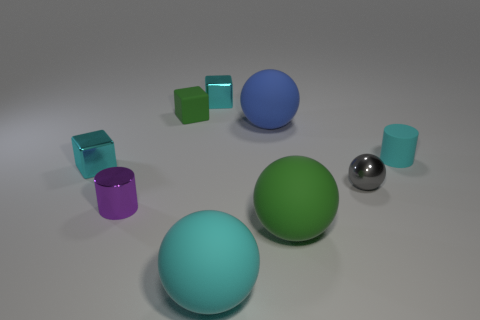What material is the ball that is the same color as the small rubber cube?
Your answer should be compact. Rubber. The green matte cube is what size?
Keep it short and to the point. Small. What number of other things are there of the same color as the shiny cylinder?
Provide a short and direct response. 0. Is the material of the cylinder in front of the small gray ball the same as the cyan cylinder?
Provide a succinct answer. No. Are there fewer cyan cubes to the left of the tiny purple object than small blocks on the left side of the big blue ball?
Make the answer very short. Yes. How many other things are made of the same material as the cyan cylinder?
Your answer should be compact. 4. What material is the green thing that is the same size as the purple shiny thing?
Your answer should be very brief. Rubber. Are there fewer metallic spheres behind the gray sphere than purple metallic cylinders?
Ensure brevity in your answer.  Yes. What is the shape of the metallic object in front of the shiny object that is to the right of the cyan metal block on the right side of the tiny purple object?
Offer a very short reply. Cylinder. There is a thing behind the tiny green object; what size is it?
Give a very brief answer. Small. 